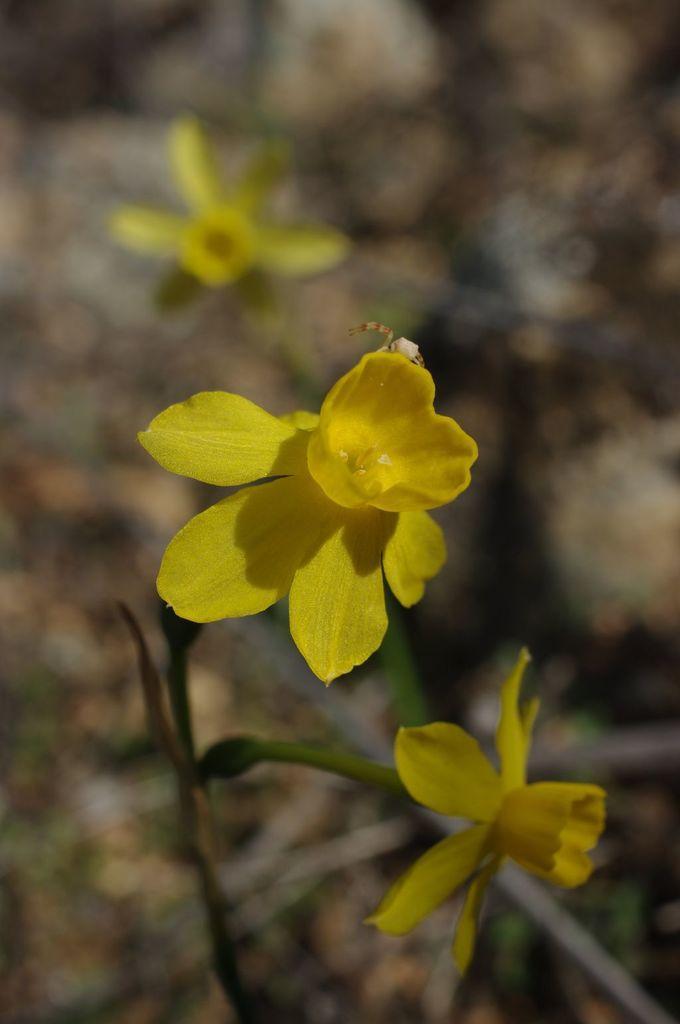In one or two sentences, can you explain what this image depicts? This image is taken outdoors. In the background there is a ground. In the middle of the image there is a plant with yellow colored flowers. 